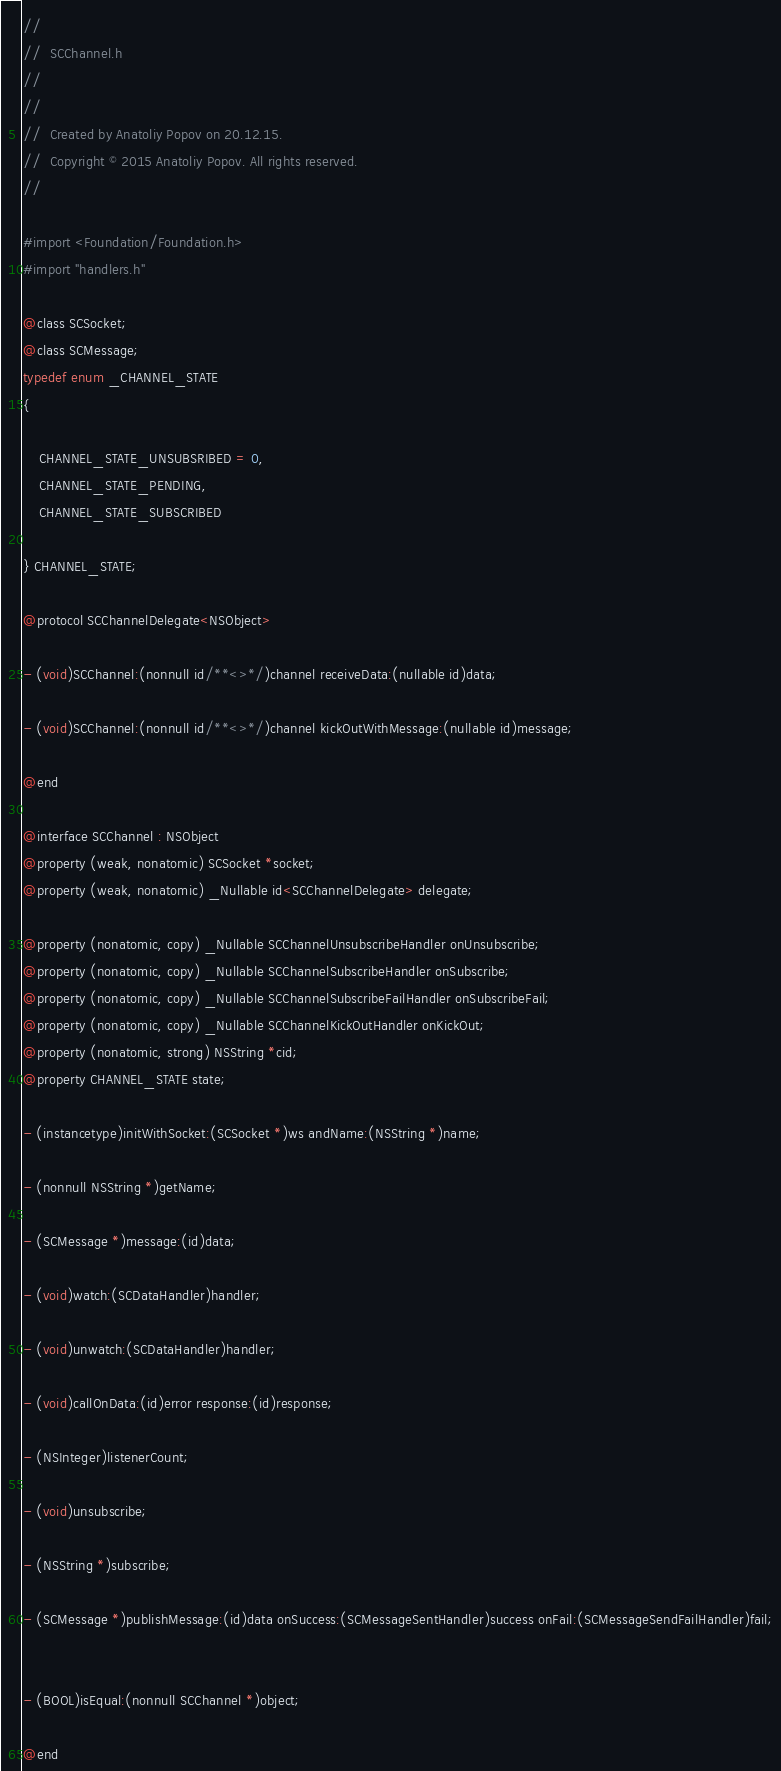<code> <loc_0><loc_0><loc_500><loc_500><_C_>//
//  SCChannel.h
//  
//
//  Created by Anatoliy Popov on 20.12.15.
//  Copyright © 2015 Anatoliy Popov. All rights reserved.
//

#import <Foundation/Foundation.h>
#import "handlers.h"

@class SCSocket;
@class SCMessage;
typedef enum _CHANNEL_STATE
{

    CHANNEL_STATE_UNSUBSRIBED = 0,
    CHANNEL_STATE_PENDING,
    CHANNEL_STATE_SUBSCRIBED

} CHANNEL_STATE;

@protocol SCChannelDelegate<NSObject>

- (void)SCChannel:(nonnull id/**<>*/)channel receiveData:(nullable id)data;

- (void)SCChannel:(nonnull id/**<>*/)channel kickOutWithMessage:(nullable id)message;

@end

@interface SCChannel : NSObject
@property (weak, nonatomic) SCSocket *socket;
@property (weak, nonatomic) _Nullable id<SCChannelDelegate> delegate;

@property (nonatomic, copy) _Nullable SCChannelUnsubscribeHandler onUnsubscribe;
@property (nonatomic, copy) _Nullable SCChannelSubscribeHandler onSubscribe;
@property (nonatomic, copy) _Nullable SCChannelSubscribeFailHandler onSubscribeFail;
@property (nonatomic, copy) _Nullable SCChannelKickOutHandler onKickOut;
@property (nonatomic, strong) NSString *cid;
@property CHANNEL_STATE state;

- (instancetype)initWithSocket:(SCSocket *)ws andName:(NSString *)name;

- (nonnull NSString *)getName;

- (SCMessage *)message:(id)data;

- (void)watch:(SCDataHandler)handler;

- (void)unwatch:(SCDataHandler)handler;

- (void)callOnData:(id)error response:(id)response;

- (NSInteger)listenerCount;

- (void)unsubscribe;

- (NSString *)subscribe;

- (SCMessage *)publishMessage:(id)data onSuccess:(SCMessageSentHandler)success onFail:(SCMessageSendFailHandler)fail;


- (BOOL)isEqual:(nonnull SCChannel *)object;

@end
</code> 